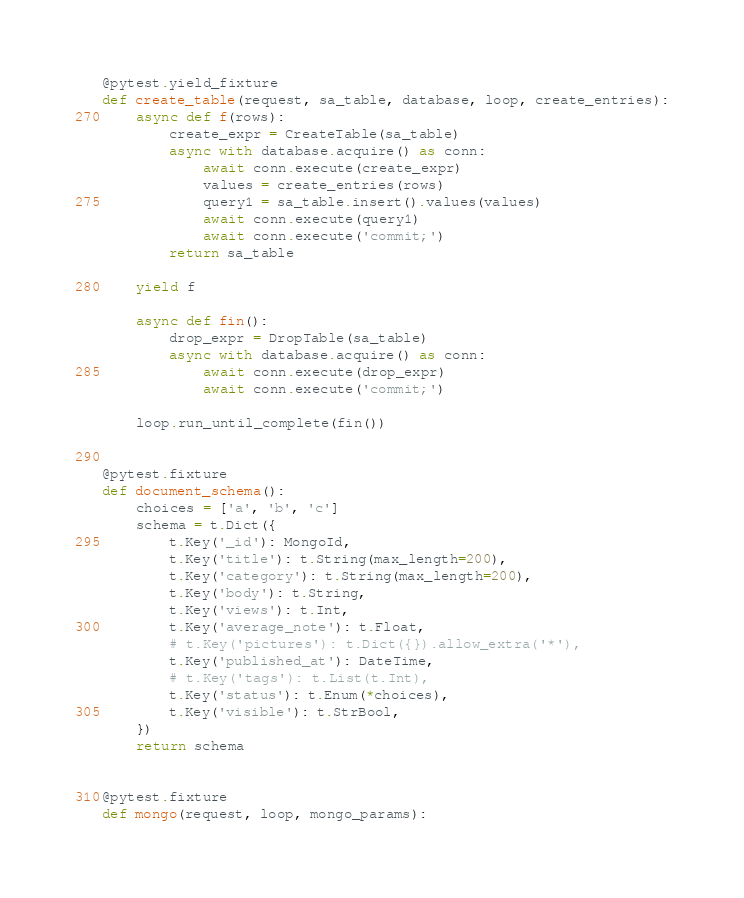<code> <loc_0><loc_0><loc_500><loc_500><_Python_>
@pytest.yield_fixture
def create_table(request, sa_table, database, loop, create_entries):
    async def f(rows):
        create_expr = CreateTable(sa_table)
        async with database.acquire() as conn:
            await conn.execute(create_expr)
            values = create_entries(rows)
            query1 = sa_table.insert().values(values)
            await conn.execute(query1)
            await conn.execute('commit;')
        return sa_table

    yield f

    async def fin():
        drop_expr = DropTable(sa_table)
        async with database.acquire() as conn:
            await conn.execute(drop_expr)
            await conn.execute('commit;')

    loop.run_until_complete(fin())


@pytest.fixture
def document_schema():
    choices = ['a', 'b', 'c']
    schema = t.Dict({
        t.Key('_id'): MongoId,
        t.Key('title'): t.String(max_length=200),
        t.Key('category'): t.String(max_length=200),
        t.Key('body'): t.String,
        t.Key('views'): t.Int,
        t.Key('average_note'): t.Float,
        # t.Key('pictures'): t.Dict({}).allow_extra('*'),
        t.Key('published_at'): DateTime,
        # t.Key('tags'): t.List(t.Int),
        t.Key('status'): t.Enum(*choices),
        t.Key('visible'): t.StrBool,
    })
    return schema


@pytest.fixture
def mongo(request, loop, mongo_params):</code> 